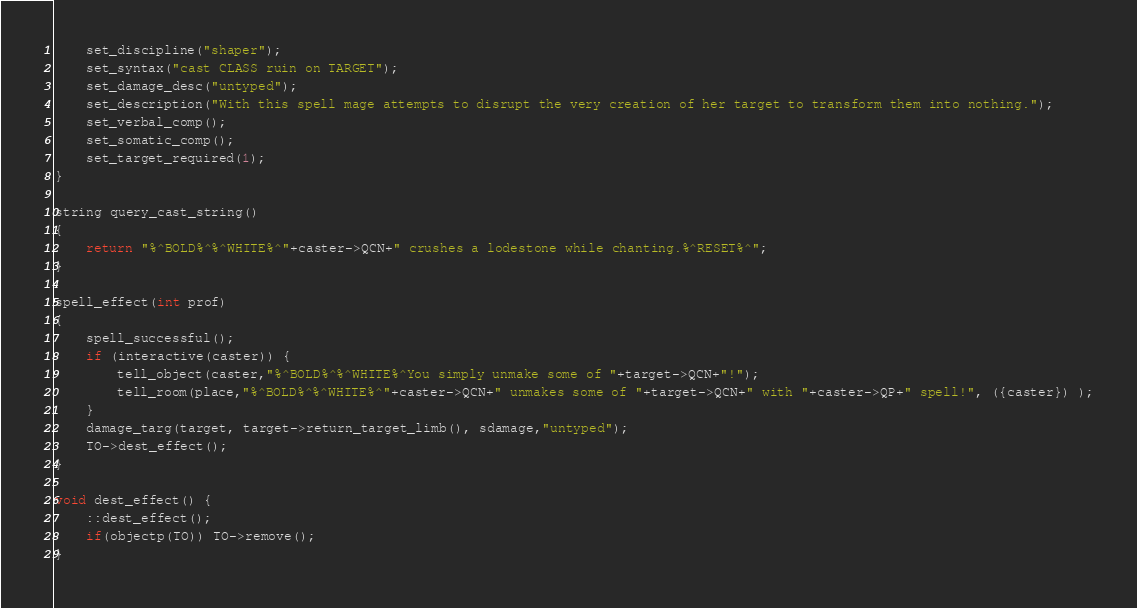Convert code to text. <code><loc_0><loc_0><loc_500><loc_500><_C_>    set_discipline("shaper");
    set_syntax("cast CLASS ruin on TARGET");
    set_damage_desc("untyped");
    set_description("With this spell mage attempts to disrupt the very creation of her target to transform them into nothing.");
    set_verbal_comp();
    set_somatic_comp();
    set_target_required(1);
}

string query_cast_string()
{
    return "%^BOLD%^%^WHITE%^"+caster->QCN+" crushes a lodestone while chanting.%^RESET%^";
}

spell_effect(int prof)
{
    spell_successful();
    if (interactive(caster)) {
        tell_object(caster,"%^BOLD%^%^WHITE%^You simply unmake some of "+target->QCN+"!");
        tell_room(place,"%^BOLD%^%^WHITE%^"+caster->QCN+" unmakes some of "+target->QCN+" with "+caster->QP+" spell!", ({caster}) );
    }
    damage_targ(target, target->return_target_limb(), sdamage,"untyped");
    TO->dest_effect();
}

void dest_effect() {
    ::dest_effect();
    if(objectp(TO)) TO->remove();
}
</code> 